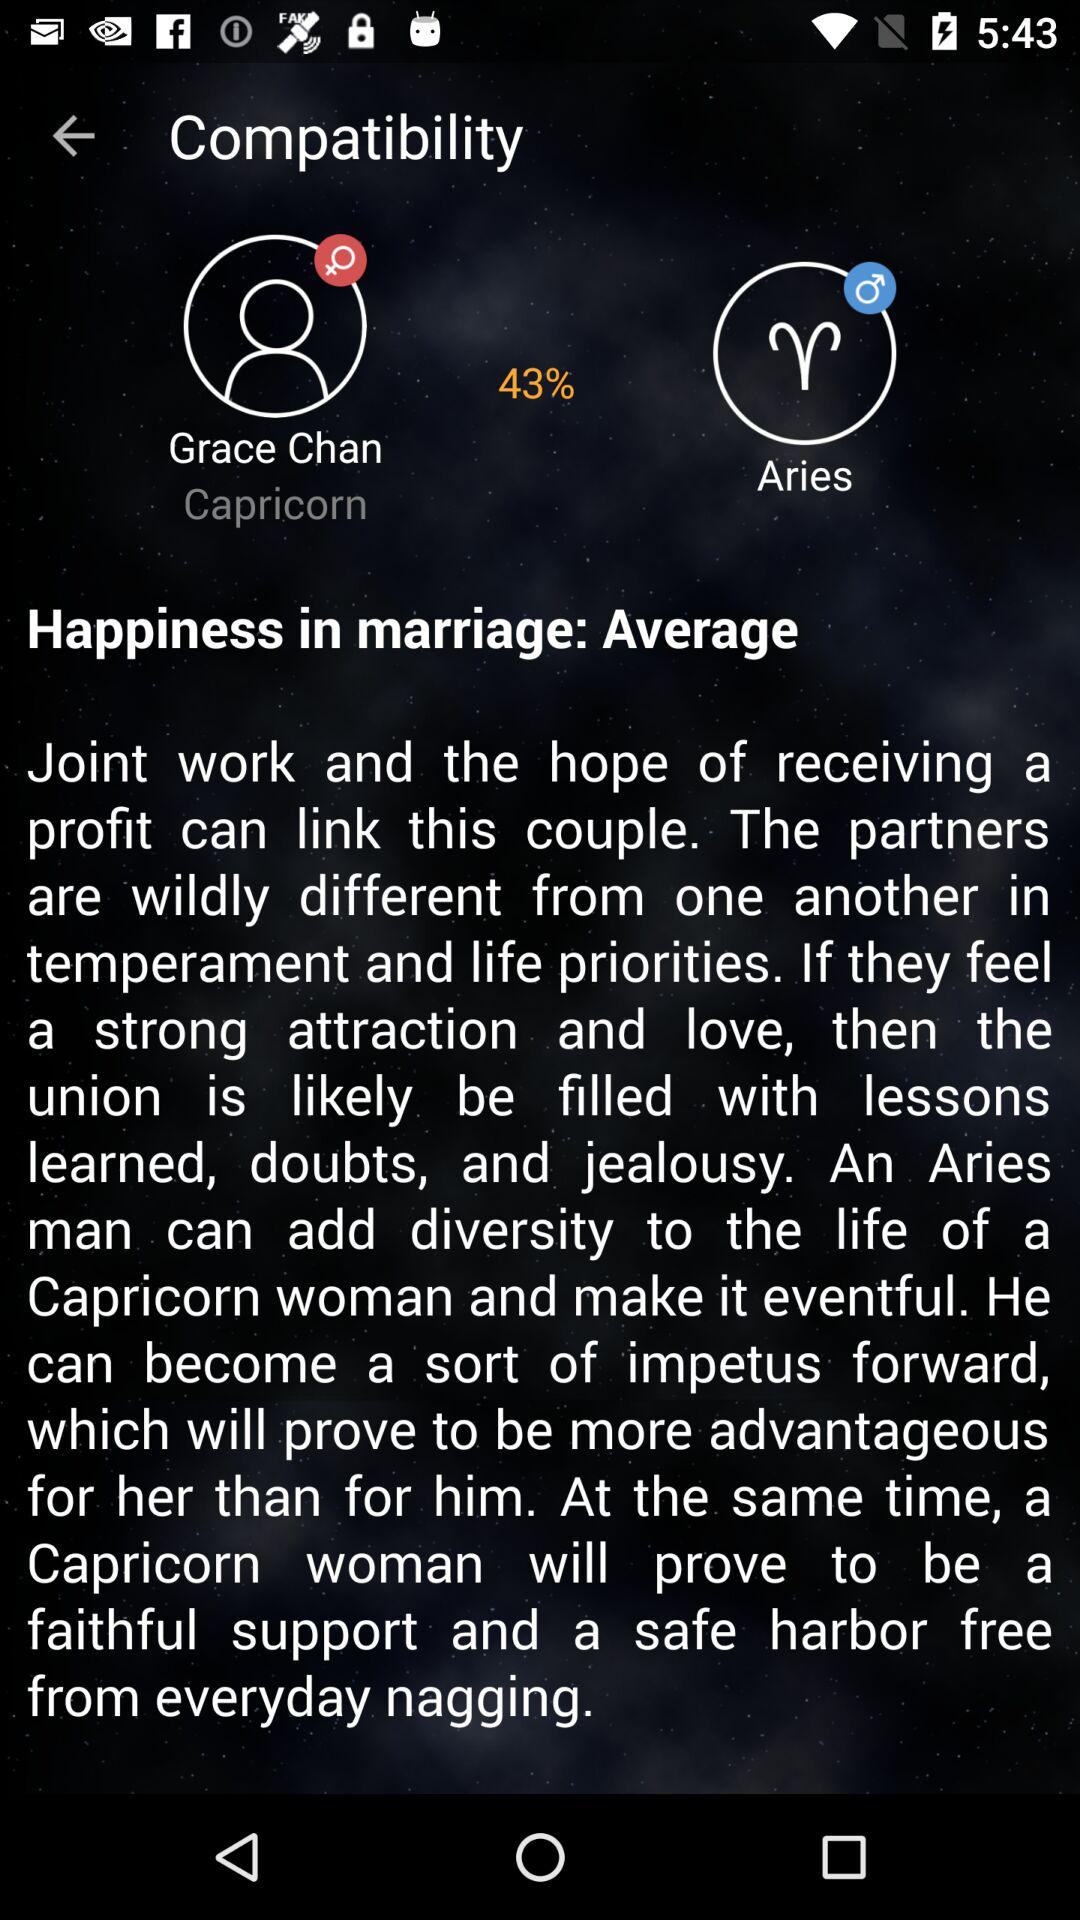What's the zodiac sign of the user? The zodiac sign of the user is Capricorn. 